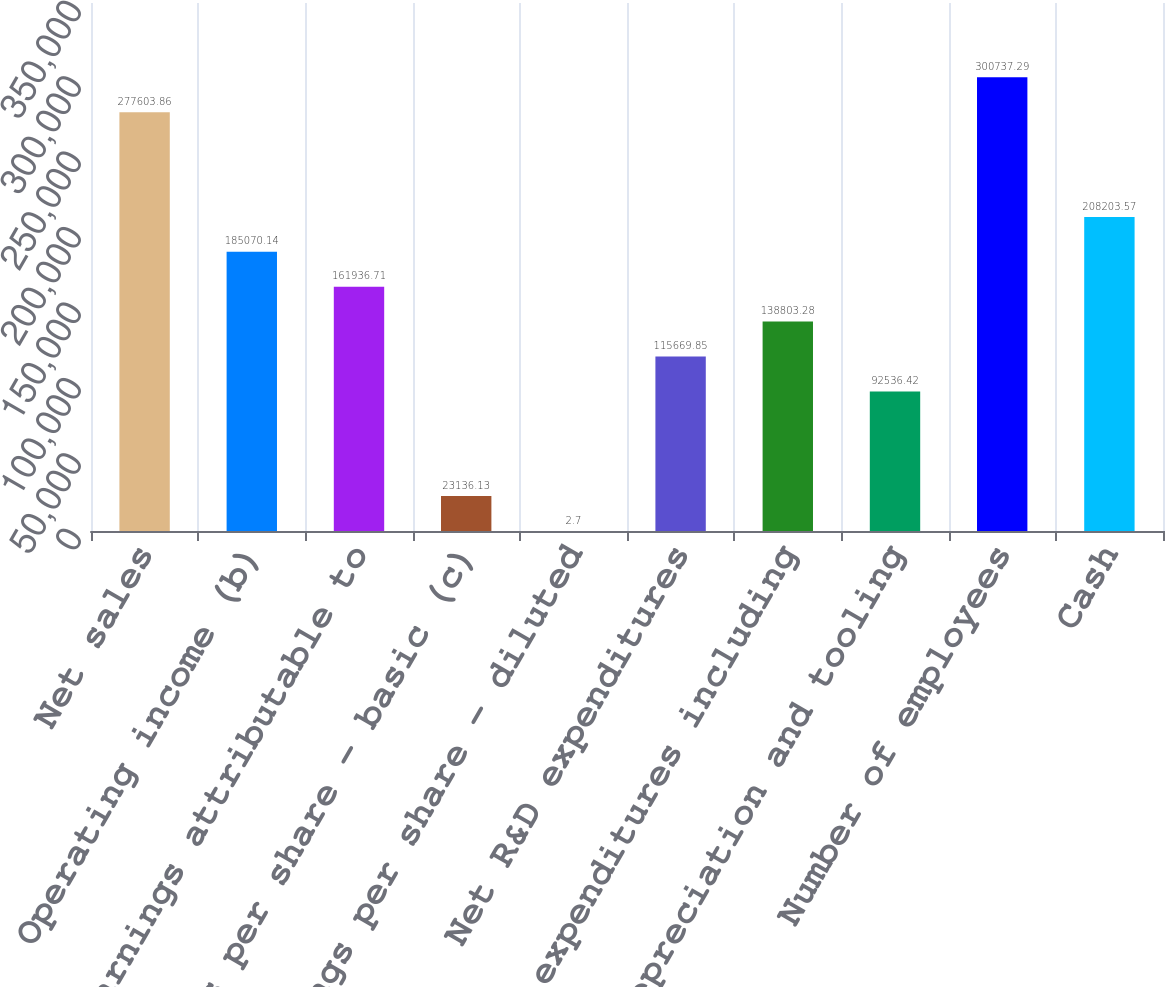Convert chart to OTSL. <chart><loc_0><loc_0><loc_500><loc_500><bar_chart><fcel>Net sales<fcel>Operating income (b)<fcel>Net earnings attributable to<fcel>Earnings per share - basic (c)<fcel>Earnings per share - diluted<fcel>Net R&D expenditures<fcel>Capital expenditures including<fcel>Depreciation and tooling<fcel>Number of employees<fcel>Cash<nl><fcel>277604<fcel>185070<fcel>161937<fcel>23136.1<fcel>2.7<fcel>115670<fcel>138803<fcel>92536.4<fcel>300737<fcel>208204<nl></chart> 